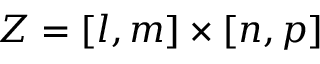Convert formula to latex. <formula><loc_0><loc_0><loc_500><loc_500>Z = [ l , m ] \times [ n , p ]</formula> 